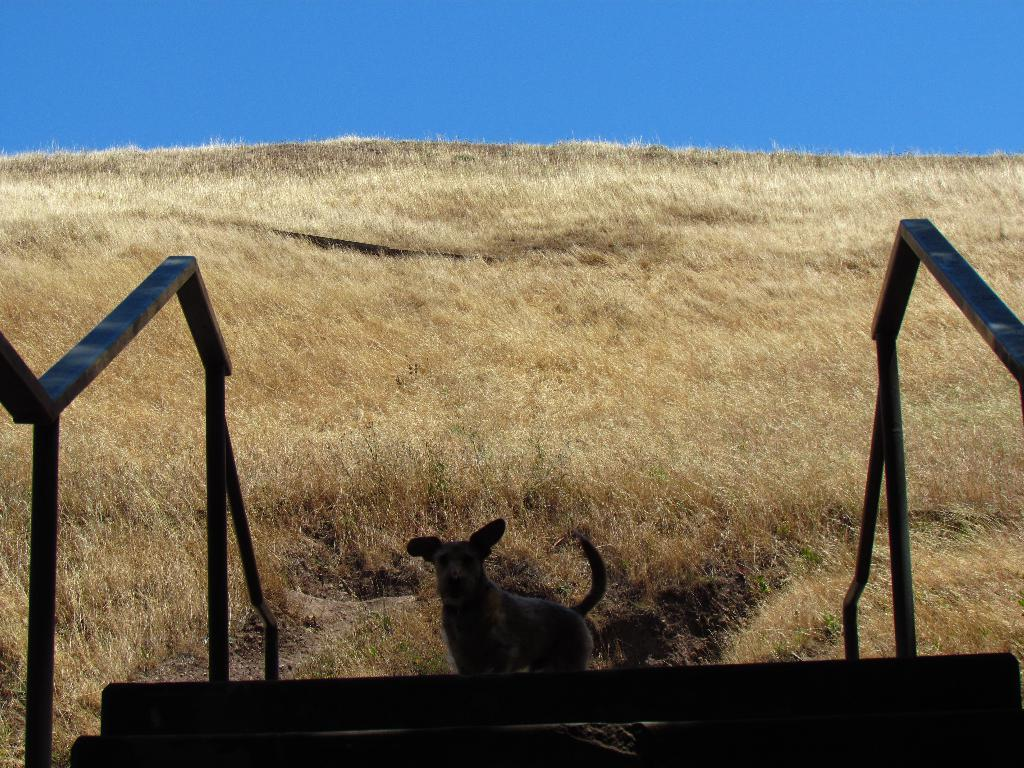What type of animal is in the image? The type of animal cannot be determined from the provided facts. Where is the animal located in the image? The animal is standing on a staircase. What feature is present on the staircase? There are handrails on the staircase. What is visible at the top of the image? The sky is visible at the top of the image. What type of vegetation is present at the bottom of the image? Grass is present at the bottom of the image. What news is the animal reading in the image? There is no indication in the image that the animal is reading any news. What is the taste of the cup in the image? There is no cup present in the image. 